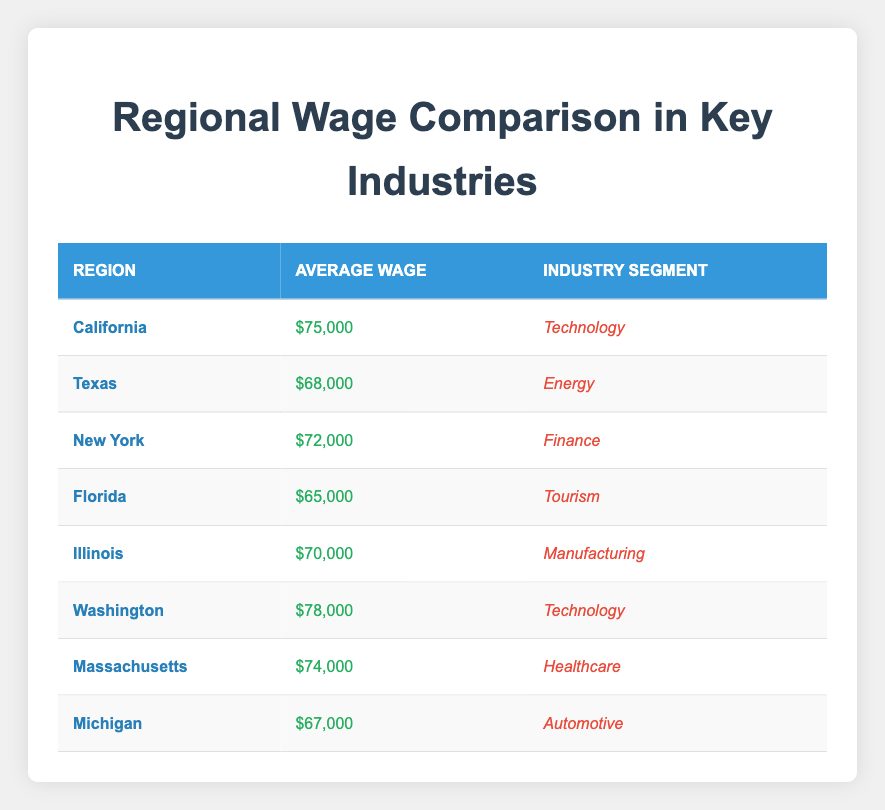What is the average wage in California? The table shows that the average wage in California is listed under the "average wage" column as $75,000.
Answer: $75,000 Which region has the highest average wage? By reviewing the wages in the table, Washington has the highest average wage of $78,000, which is higher than all other regions listed.
Answer: Washington What is the average wage for the Technology industry segment across the regions? The average wages for the Technology segment are $75,000 (California) and $78,000 (Washington). To find the average, sum these two values (75,000 + 78,000 = 153,000) and divide by 2, giving us an average of 153,000 / 2 = 76,500.
Answer: $76,500 Is the average wage in Florida lower than in Michigan? The average wage in Florida is $65,000, while in Michigan it is $67,000. Since $65,000 is indeed less than $67,000, Florida has a lower wage compared to Michigan.
Answer: Yes What is the difference in average wage between the highest-paying and lowest-paying regions? The highest average wage is in Washington at $78,000, and the lowest is in Florida at $65,000. The difference is $78,000 - $65,000 = $13,000.
Answer: $13,000 How does the average wage in New York compare to that in Texas? The average wage in New York is $72,000 and in Texas is $68,000. Since $72,000 is greater than $68,000, New York has a higher wage compared to Texas.
Answer: New York has a higher wage What industry segment has the lowest average wage listed in the table? Looking at the table, Florida with Tourism has the lowest average wage at $65,000 when compared to all other segments.
Answer: Tourism If we group the average wages by segments, which segment has an average wage higher than $70,000? The segments listed with average wages above $70,000 are Technology ($76,500), Finance ($72,000), Healthcare ($74,000), and Manufacturing ($70,000). Thus, Manufacturing is not included as it is exactly $70,000.
Answer: Technology, Finance, and Healthcare What is the total average wage of all the regions combined? Summing all the average wages: $75,000 + $68,000 + $72,000 + $65,000 + $70,000 + $78,000 + $74,000 + $67,000 gives us a total of $600,000. To find the average, we divide by 8 (the number of regions): $600,000 / 8 = $75,000.
Answer: $75,000 